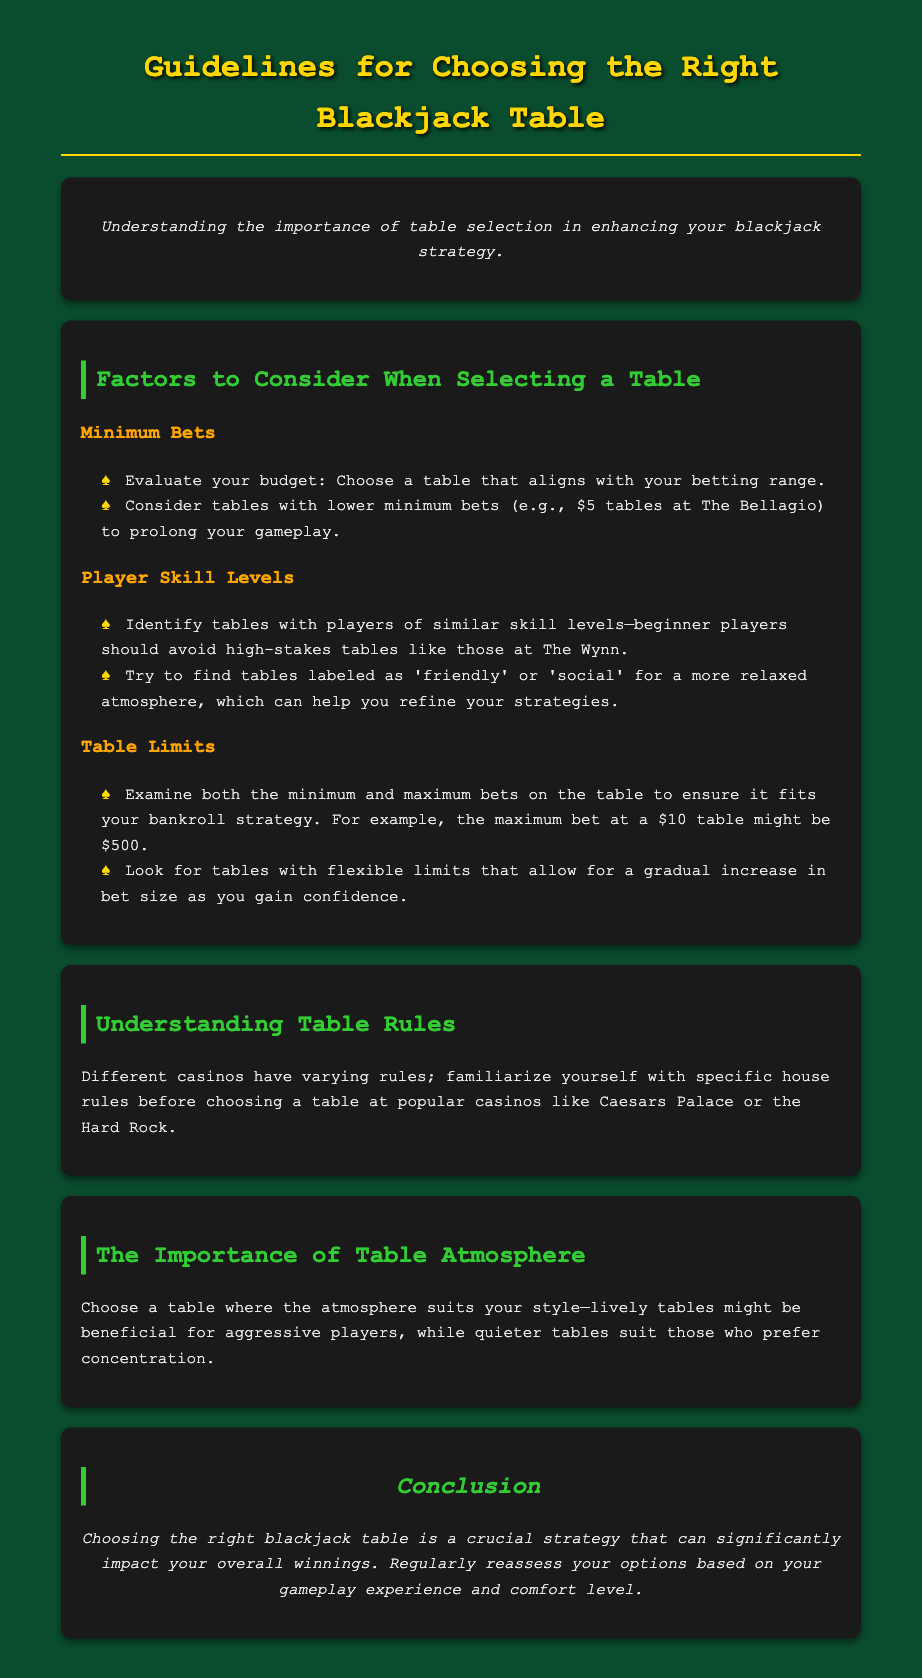What are the two main factors to consider when selecting a table? The document mentions minimum bets and player skill levels as key factors to consider.
Answer: minimum bets, player skill levels What is a recommended minimum bet at The Bellagio? The document states that tables with lower minimum bets, such as $5 tables at The Bellagio, can be beneficial.
Answer: $5 What type of tables should beginner players avoid? The document advises beginner players to avoid high-stakes tables like those at The Wynn.
Answer: high-stakes tables What should players examine regarding table limits? The document suggests examining both minimum and maximum bets on the table.
Answer: minimum and maximum bets What is the maximum bet at a $10 table? The document gives an example where the maximum bet at a $10 table might be $500.
Answer: $500 What is crucial for a player's overall winnings according to the conclusion? The conclusion emphasizes choosing the right blackjack table as crucial for impacting overall winnings.
Answer: choosing the right blackjack table What type of atmosphere might benefit aggressive players? The document mentions that lively tables might be beneficial for aggressive players.
Answer: lively tables What two different styles of players are mentioned regarding table atmosphere? The document contrasts aggressive players with those who prefer concentration.
Answer: aggressive players, those who prefer concentration Which casinos are mentioned in relation to varying house rules? The document refers to popular casinos like Caesars Palace or the Hard Rock regarding house rules.
Answer: Caesars Palace, Hard Rock 